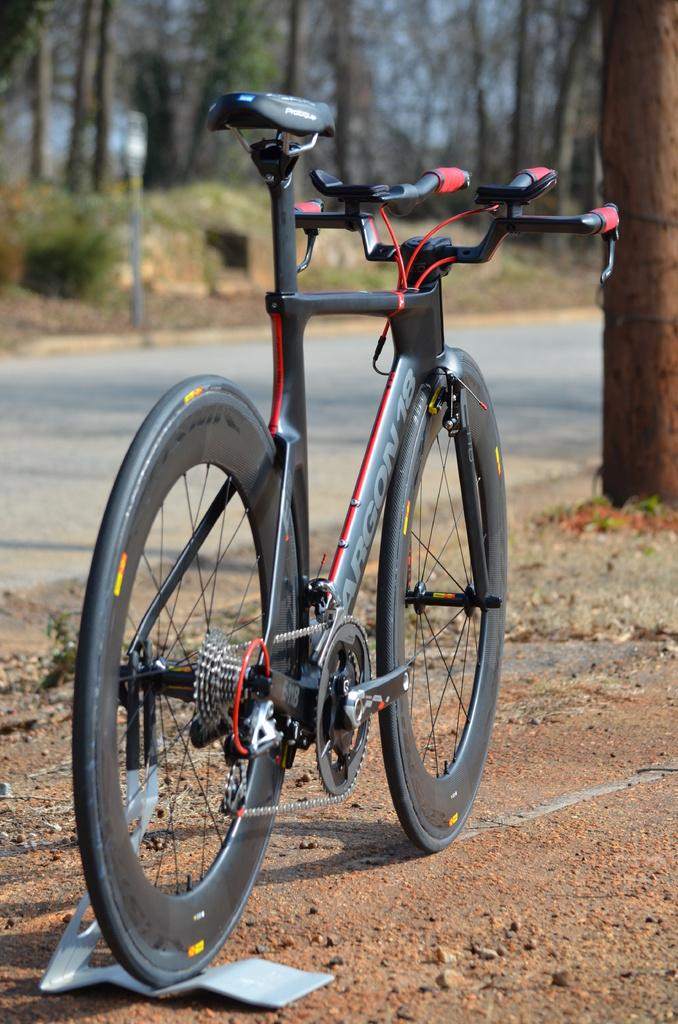What is the main object in the center of the image? There is a bicycle on a stand in the center of the image. What can be seen in the background of the image? There are trees and a pole in the background of the image. What is at the bottom of the image? There is a road and the ground visible at the bottom of the image. What type of amusement can be seen in the image? There is no amusement present in the image; it features a bicycle on a stand and other elements mentioned in the conversation. Can you tell me how many lawyers are visible in the image? There are no lawyers present in the image. 